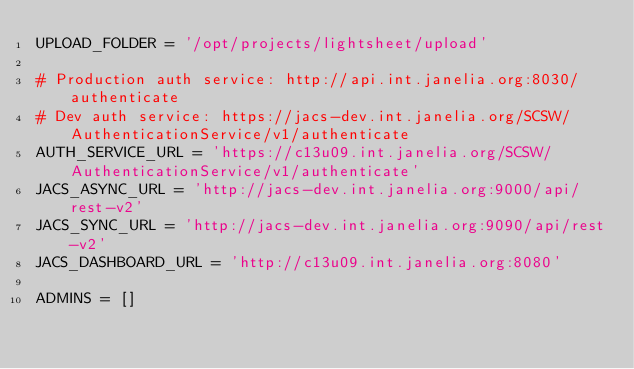<code> <loc_0><loc_0><loc_500><loc_500><_Python_>UPLOAD_FOLDER = '/opt/projects/lightsheet/upload'

# Production auth service: http://api.int.janelia.org:8030/authenticate
# Dev auth service: https://jacs-dev.int.janelia.org/SCSW/AuthenticationService/v1/authenticate
AUTH_SERVICE_URL = 'https://c13u09.int.janelia.org/SCSW/AuthenticationService/v1/authenticate'
JACS_ASYNC_URL = 'http://jacs-dev.int.janelia.org:9000/api/rest-v2'
JACS_SYNC_URL = 'http://jacs-dev.int.janelia.org:9090/api/rest-v2'
JACS_DASHBOARD_URL = 'http://c13u09.int.janelia.org:8080'

ADMINS = []</code> 